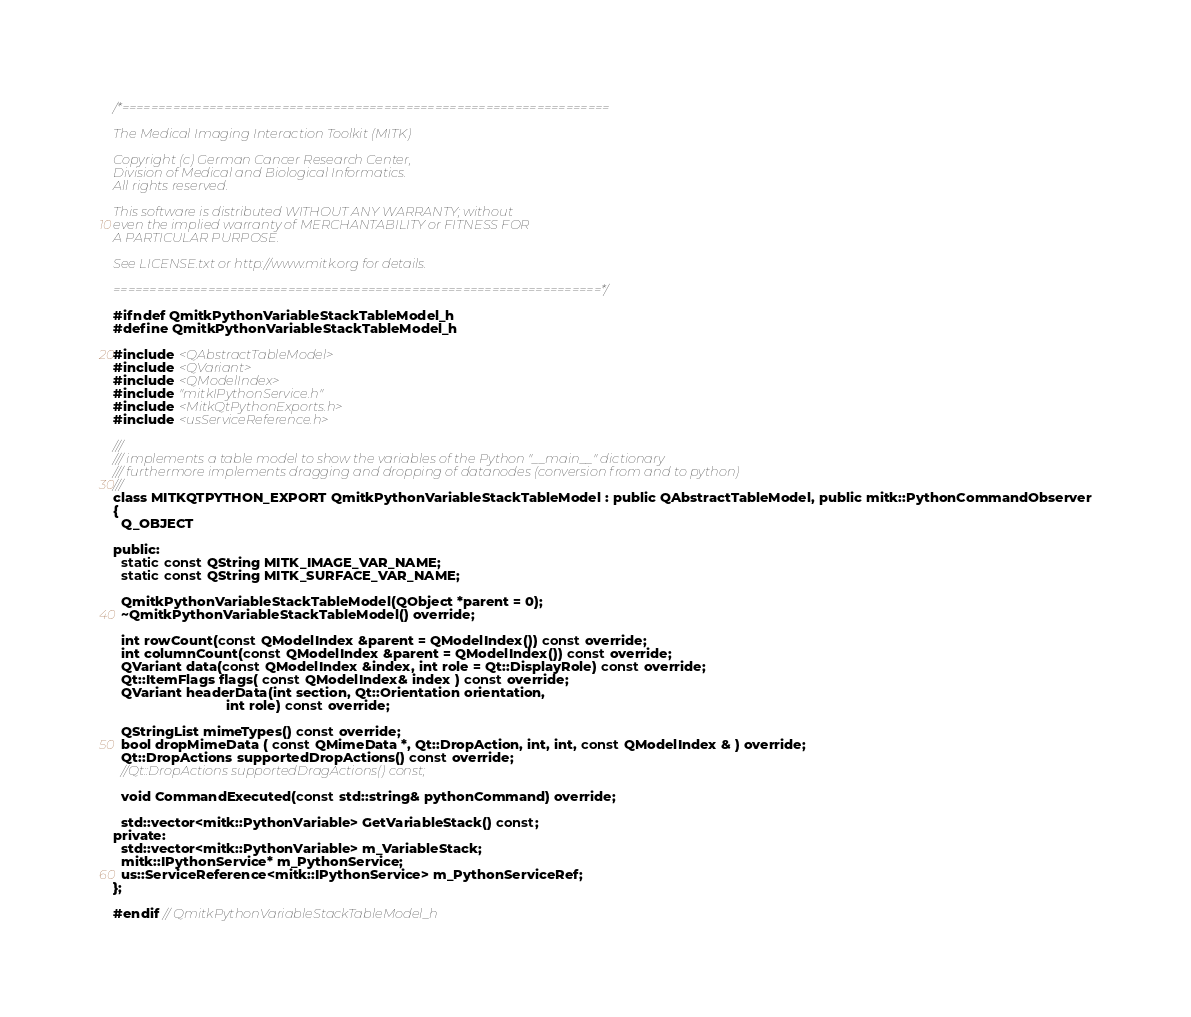Convert code to text. <code><loc_0><loc_0><loc_500><loc_500><_C_>/*===================================================================

The Medical Imaging Interaction Toolkit (MITK)

Copyright (c) German Cancer Research Center,
Division of Medical and Biological Informatics.
All rights reserved.

This software is distributed WITHOUT ANY WARRANTY; without
even the implied warranty of MERCHANTABILITY or FITNESS FOR
A PARTICULAR PURPOSE.

See LICENSE.txt or http://www.mitk.org for details.

===================================================================*/

#ifndef QmitkPythonVariableStackTableModel_h
#define QmitkPythonVariableStackTableModel_h

#include <QAbstractTableModel>
#include <QVariant>
#include <QModelIndex>
#include "mitkIPythonService.h"
#include <MitkQtPythonExports.h>
#include <usServiceReference.h>

///
/// implements a table model to show the variables of the Python "__main__" dictionary
/// furthermore implements dragging and dropping of datanodes (conversion from and to python)
///
class MITKQTPYTHON_EXPORT QmitkPythonVariableStackTableModel : public QAbstractTableModel, public mitk::PythonCommandObserver
{
  Q_OBJECT

public:
  static const QString MITK_IMAGE_VAR_NAME;
  static const QString MITK_SURFACE_VAR_NAME;

  QmitkPythonVariableStackTableModel(QObject *parent = 0);
  ~QmitkPythonVariableStackTableModel() override;

  int rowCount(const QModelIndex &parent = QModelIndex()) const override;
  int columnCount(const QModelIndex &parent = QModelIndex()) const override;
  QVariant data(const QModelIndex &index, int role = Qt::DisplayRole) const override;
  Qt::ItemFlags flags( const QModelIndex& index ) const override;
  QVariant headerData(int section, Qt::Orientation orientation,
                              int role) const override;

  QStringList mimeTypes() const override;
  bool dropMimeData ( const QMimeData *, Qt::DropAction, int, int, const QModelIndex & ) override;
  Qt::DropActions supportedDropActions() const override;
  //Qt::DropActions supportedDragActions() const;

  void CommandExecuted(const std::string& pythonCommand) override;

  std::vector<mitk::PythonVariable> GetVariableStack() const;
private:
  std::vector<mitk::PythonVariable> m_VariableStack;
  mitk::IPythonService* m_PythonService;
  us::ServiceReference<mitk::IPythonService> m_PythonServiceRef;
};

#endif // QmitkPythonVariableStackTableModel_h
</code> 